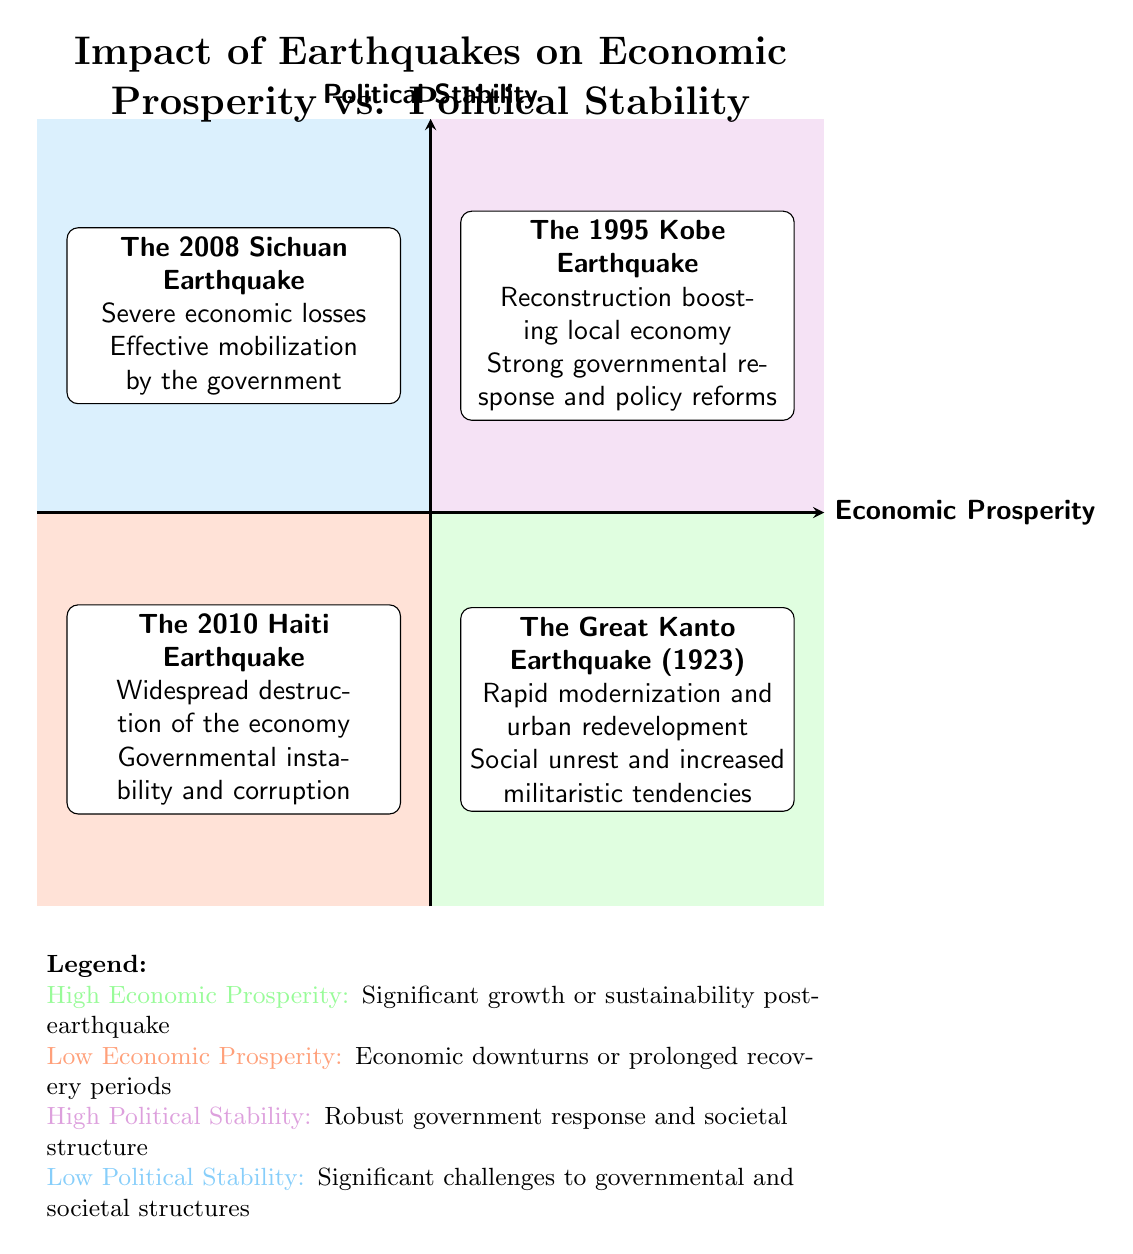What event is located in the "High Economic Prosperity / Low Political Stability" quadrant? The event listed in the "High Economic Prosperity / Low Political Stability" quadrant is "The Great Kanto Earthquake (1923)." This is determined by identifying the specific quadrant and reading the event description provided within the designated box.
Answer: The Great Kanto Earthquake (1923) How many events are shown in the "Low Economic Prosperity / Low Political Stability" quadrant? There is one event in the "Low Economic Prosperity / Low Political Stability" quadrant, which is "The 2010 Haiti Earthquake." This can be confirmed by counting the events listed in that specific quadrant's box.
Answer: 1 What was the political impact of the 1995 Kobe Earthquake? The political impact of the 1995 Kobe Earthquake was a "Strong governmental response, leading to policy reforms and resilience measures." This is found by reading the content within the corresponding quadrant for that specific event.
Answer: Strong governmental response, leading to policy reforms and resilience measures Which earthquake event is associated with "widespread destruction of the economy"? "The 2010 Haiti Earthquake" is associated with "widespread destruction of the economy." To find this, one references the "Low Economic Prosperity / Low Political Stability" quadrant and identifies the economic impact related to that event.
Answer: The 2010 Haiti Earthquake What are the two possible characteristics of regions in the "High Economic Prosperity / High Political Stability" quadrant? The regions in this quadrant can experience "significant economic growth or sustainability post-earthquake" and exhibit "robust government response and societal structure." These definitions are derived from the legend, which outlines the traits of each quadrant category.
Answer: Significant economic growth or sustainability post-earthquake; robust government response and societal structure What was the economic impact described for the 2008 Sichuan Earthquake? The economic impact of the 2008 Sichuan Earthquake was "Severe economic losses in a region highly dependent on agriculture and industry." This information is obtained by analyzing the description of the event in the "Low Economic Prosperity / High Political Stability" quadrant.
Answer: Severe economic losses in a region highly dependent on agriculture and industry Compare the political stability of the "Great Kanto Earthquake" and "Kobe Earthquake." The Great Kanto Earthquake had "Low Political Stability" characterized by "Social unrest and increased militaristic tendencies," whereas the Kobe Earthquake had "High Political Stability" with a "Strong governmental response." This comparison involves analyzing the political impact mentioned for each earthquake event within their respective quadrants.
Answer: Low Political Stability vs. High Political Stability What is the main theme or purpose of the quadrant chart? The main theme of the quadrant chart is to illustrate the "Impact of Earthquakes on Economic Prosperity vs. Political Stability." This can be identified from the title at the top of the diagram, which explicitly states the focus of the data presented within the quadrants.
Answer: Impact of Earthquakes on Economic Prosperity vs. Political Stability 